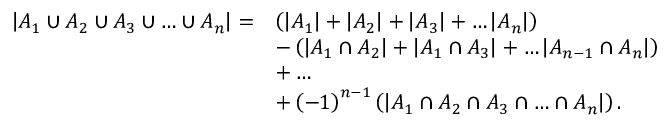<formula> <loc_0><loc_0><loc_500><loc_500>{ \begin{array} { r l } { \left | A _ { 1 } \cup A _ { 2 } \cup A _ { 3 } \cup \dots \cup A _ { n } \right | = } & { \left ( \left | A _ { 1 } \right | + \left | A _ { 2 } \right | + \left | A _ { 3 } \right | + \dots \left | A _ { n } \right | \right ) } \\ & { - \left ( \left | A _ { 1 } \cap A _ { 2 } \right | + \left | A _ { 1 } \cap A _ { 3 } \right | + \dots \left | A _ { n - 1 } \cap A _ { n } \right | \right ) } \\ & { + \dots } \\ & { + \left ( - 1 \right ) ^ { n - 1 } \left ( \left | A _ { 1 } \cap A _ { 2 } \cap A _ { 3 } \cap \dots \cap A _ { n } \right | \right ) . } \end{array} }</formula> 